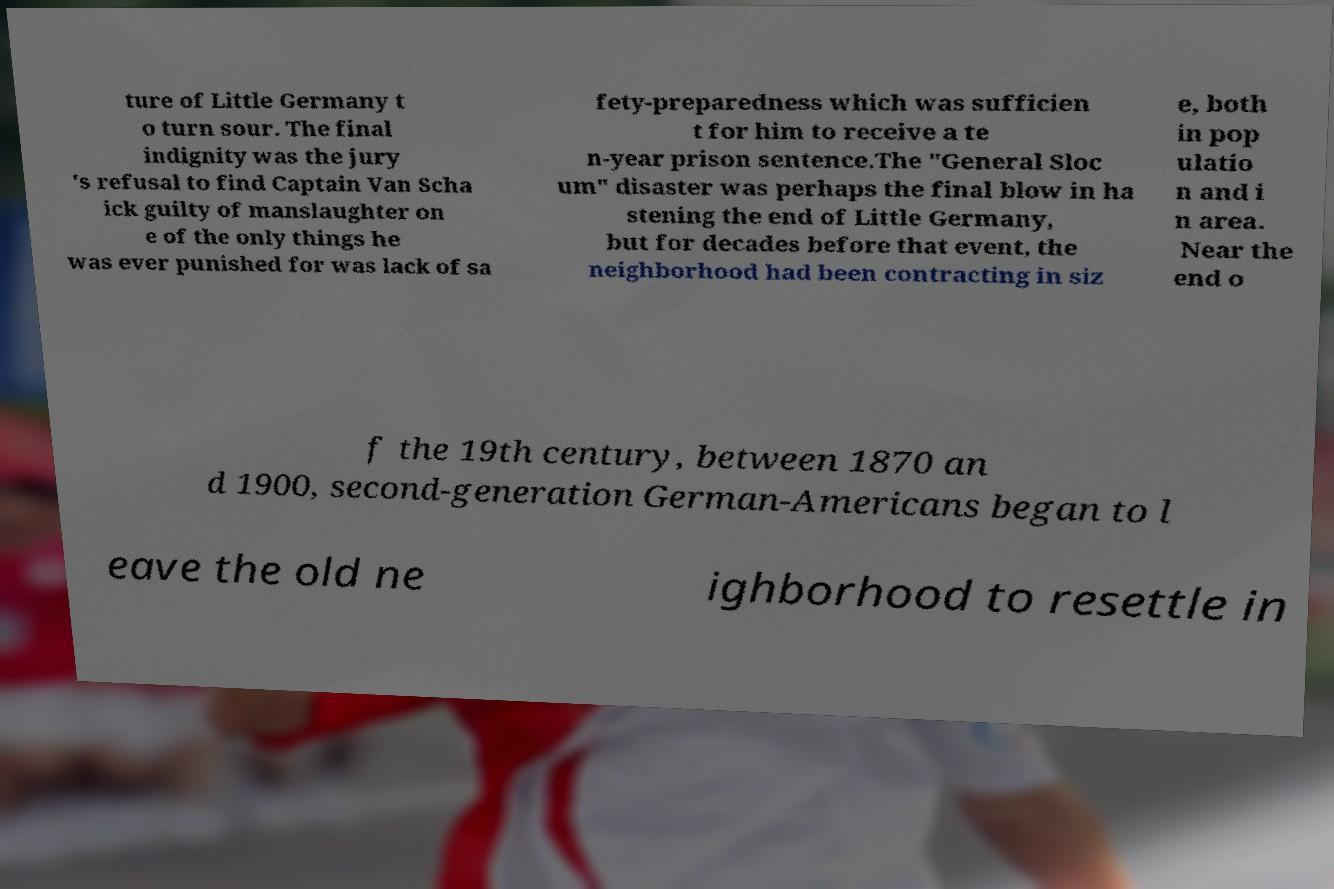I need the written content from this picture converted into text. Can you do that? ture of Little Germany t o turn sour. The final indignity was the jury 's refusal to find Captain Van Scha ick guilty of manslaughter on e of the only things he was ever punished for was lack of sa fety-preparedness which was sufficien t for him to receive a te n-year prison sentence.The "General Sloc um" disaster was perhaps the final blow in ha stening the end of Little Germany, but for decades before that event, the neighborhood had been contracting in siz e, both in pop ulatio n and i n area. Near the end o f the 19th century, between 1870 an d 1900, second-generation German-Americans began to l eave the old ne ighborhood to resettle in 